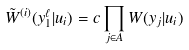Convert formula to latex. <formula><loc_0><loc_0><loc_500><loc_500>\tilde { W } ^ { ( i ) } ( y _ { 1 } ^ { \ell } | u _ { i } ) = c \prod _ { j \in A } W ( y _ { j } | u _ { i } )</formula> 